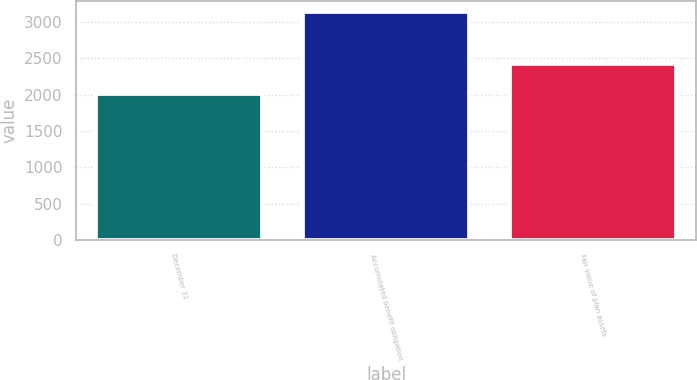<chart> <loc_0><loc_0><loc_500><loc_500><bar_chart><fcel>December 31<fcel>Accumulated benefit obligation<fcel>Fair value of plan assets<nl><fcel>2009<fcel>3139<fcel>2418<nl></chart> 